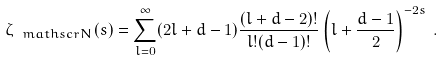Convert formula to latex. <formula><loc_0><loc_0><loc_500><loc_500>\zeta _ { { \ m a t h s c r { N } } } ( s ) = \sum _ { l = 0 } ^ { \infty } ( 2 l + d - 1 ) \frac { ( l + d - 2 ) ! } { l ! ( d - 1 ) ! } \left ( l + \frac { d - 1 } { 2 } \right ) ^ { - 2 s } \, .</formula> 